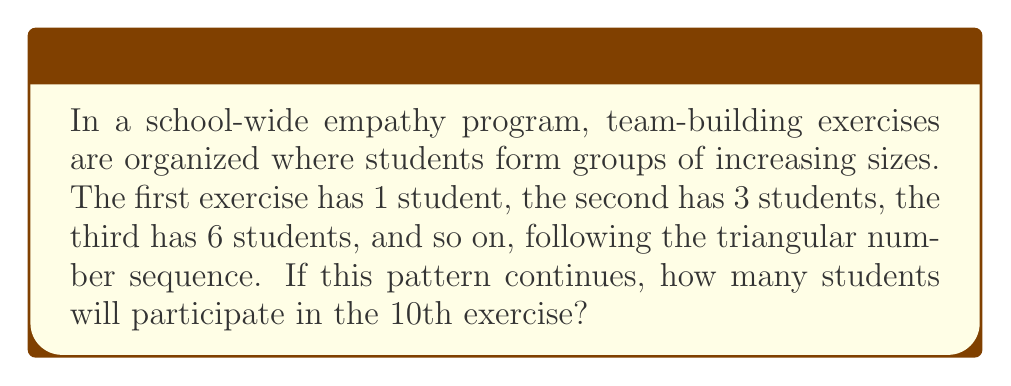Could you help me with this problem? To solve this problem, we need to understand the triangular number sequence and apply it to find the 10th term. Let's break it down step-by-step:

1) The triangular number sequence is formed by the cumulative sum of natural numbers:
   $T_n = 1 + 2 + 3 + ... + n$

2) There's a formula to calculate the nth triangular number:
   $T_n = \frac{n(n+1)}{2}$

3) In this case, we need to find $T_{10}$, the 10th triangular number:
   $T_{10} = \frac{10(10+1)}{2}$

4) Let's calculate:
   $T_{10} = \frac{10(11)}{2} = \frac{110}{2} = 55$

5) We can verify this by listing out the first few triangular numbers:
   $T_1 = 1$
   $T_2 = 1 + 2 = 3$
   $T_3 = 1 + 2 + 3 = 6$
   $T_4 = 1 + 2 + 3 + 4 = 10$
   ...
   $T_{10} = 1 + 2 + 3 + 4 + 5 + 6 + 7 + 8 + 9 + 10 = 55$

Therefore, in the 10th exercise, 55 students will participate.
Answer: 55 students 